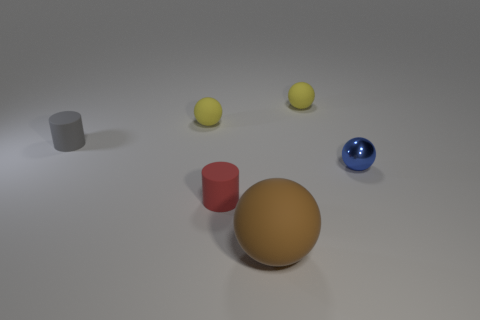What number of things are either large gray metallic cubes or large brown matte objects?
Provide a short and direct response. 1. There is a small matte sphere that is on the right side of the small ball that is left of the tiny object that is in front of the metal ball; what color is it?
Give a very brief answer. Yellow. Is there anything else of the same color as the big object?
Your response must be concise. No. Do the metal thing and the brown object have the same size?
Offer a very short reply. No. How many things are matte balls that are behind the brown rubber sphere or small objects that are to the left of the big brown object?
Offer a very short reply. 4. There is a small cylinder that is to the left of the cylinder in front of the tiny gray rubber thing; what is its material?
Offer a very short reply. Rubber. How many other things are made of the same material as the large brown object?
Offer a terse response. 4. Does the tiny red rubber object have the same shape as the small blue shiny object?
Your response must be concise. No. What is the size of the cylinder right of the gray matte object?
Make the answer very short. Small. Does the brown matte sphere have the same size as the red thing that is on the left side of the brown object?
Your answer should be very brief. No. 